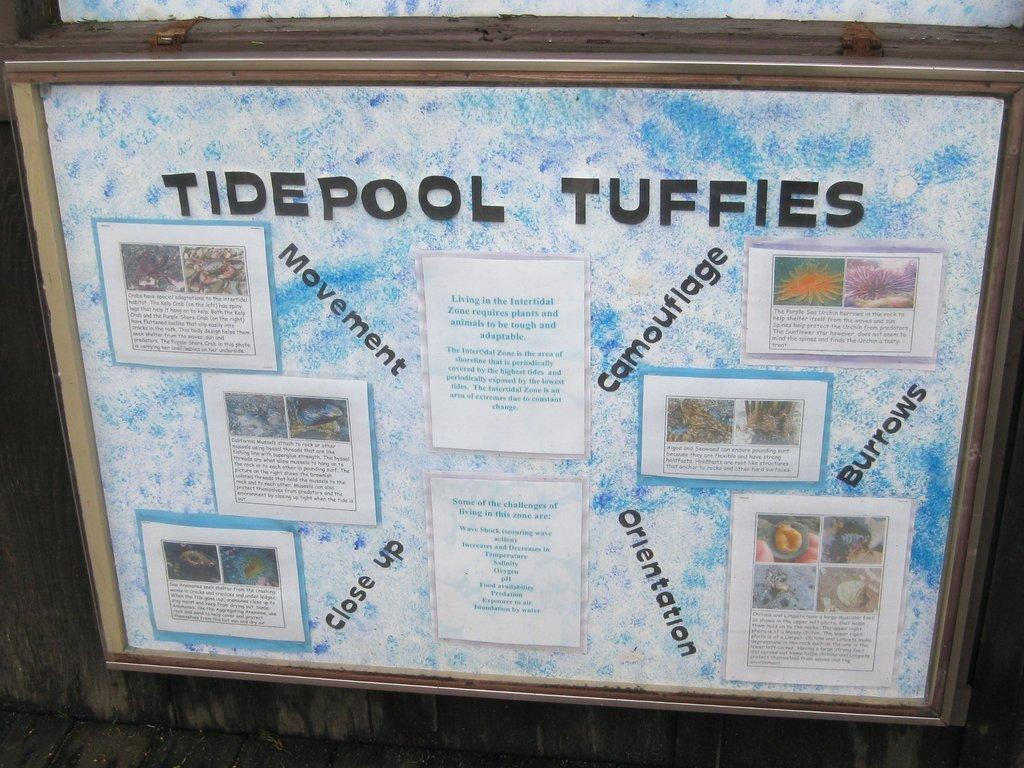<image>
Present a compact description of the photo's key features. An informational display of Tidepool Tuffies featuring five sections. 